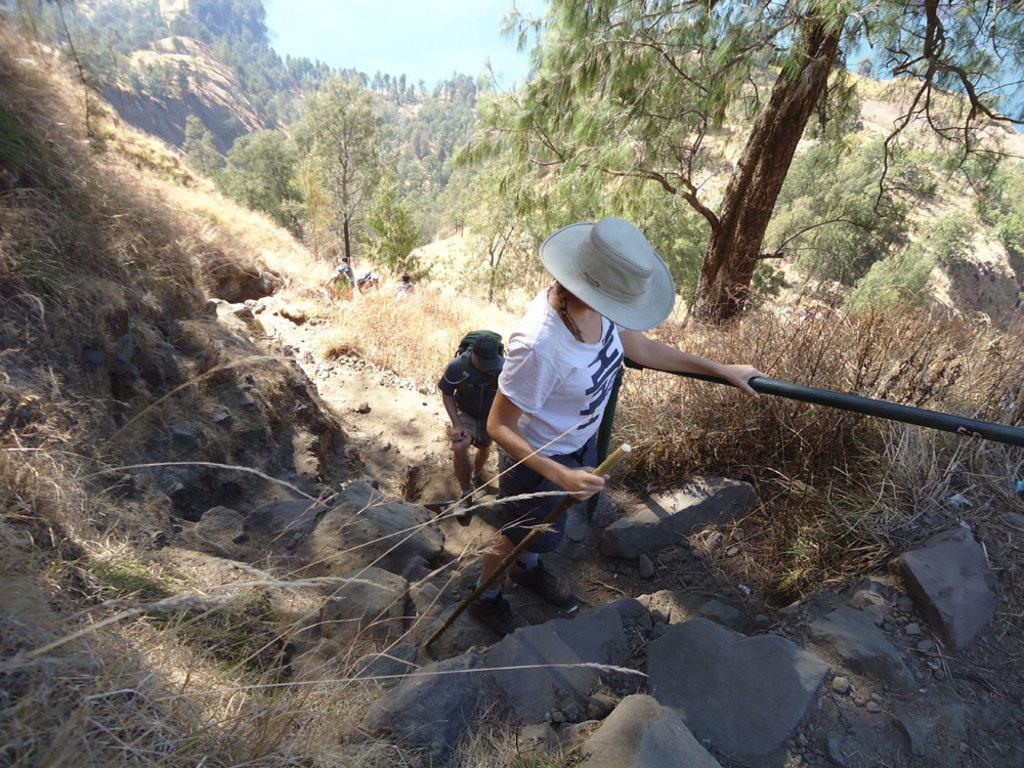How many people are present in the image? There are two people in the image. What is one person holding in the image? One person is holding a rod. What can be seen in the background of the image? There are trees and dried plants in the background of the image. What type of silk is being used to comfort the substance in the image? There is no silk, comfort, or substance present in the image. 